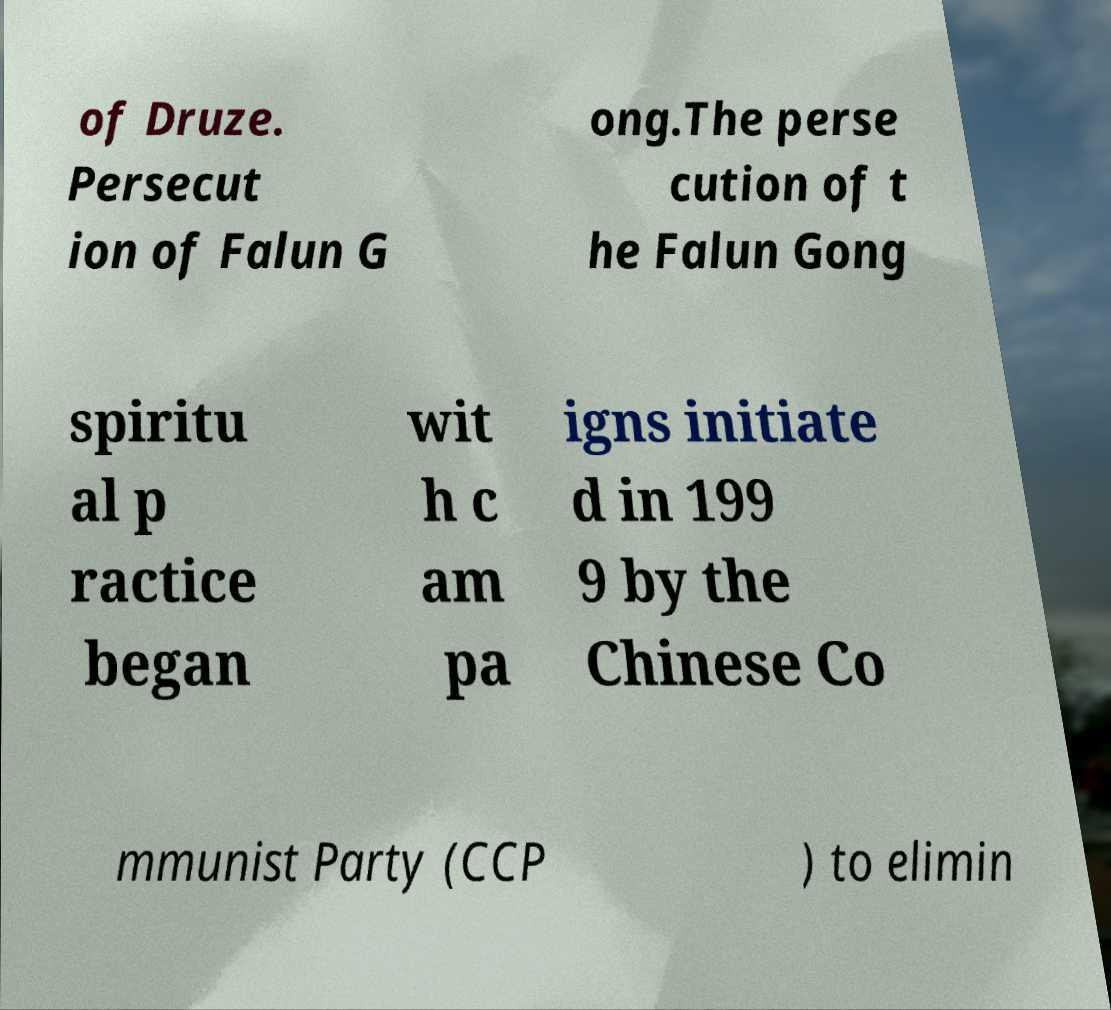I need the written content from this picture converted into text. Can you do that? of Druze. Persecut ion of Falun G ong.The perse cution of t he Falun Gong spiritu al p ractice began wit h c am pa igns initiate d in 199 9 by the Chinese Co mmunist Party (CCP ) to elimin 